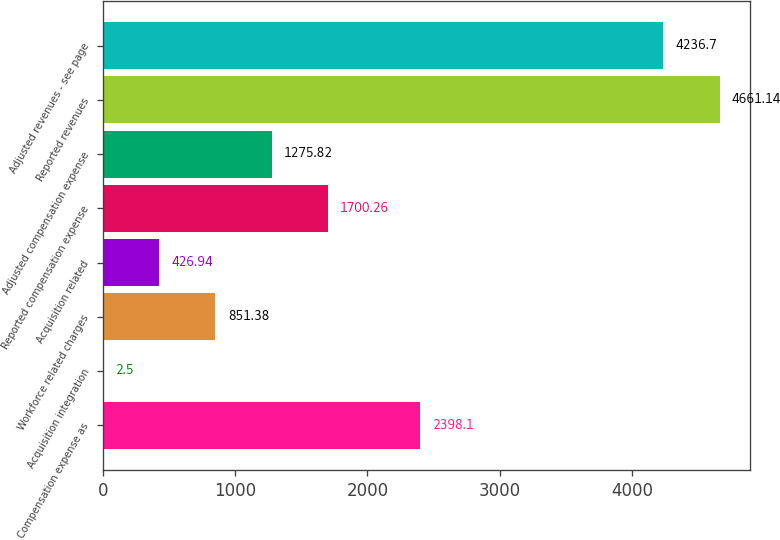<chart> <loc_0><loc_0><loc_500><loc_500><bar_chart><fcel>Compensation expense as<fcel>Acquisition integration<fcel>Workforce related charges<fcel>Acquisition related<fcel>Reported compensation expense<fcel>Adjusted compensation expense<fcel>Reported revenues<fcel>Adjusted revenues - see page<nl><fcel>2398.1<fcel>2.5<fcel>851.38<fcel>426.94<fcel>1700.26<fcel>1275.82<fcel>4661.14<fcel>4236.7<nl></chart> 